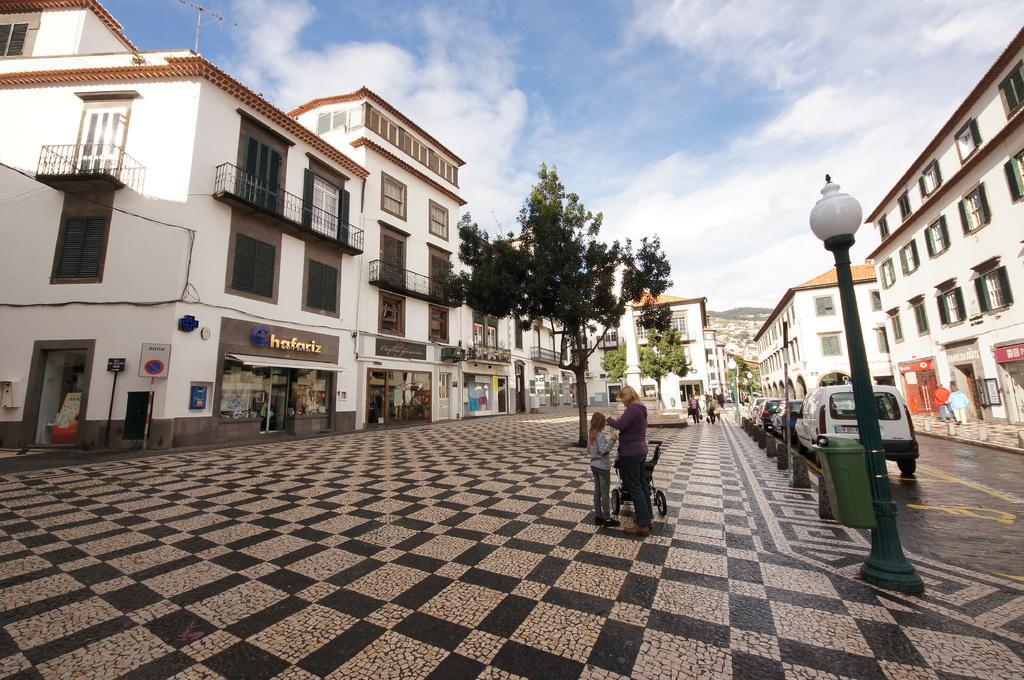How would you summarize this image in a sentence or two? In this image, there are a few buildings. We can see the ground with some objects. We can see some boards with text. There are a few poles. We can see a container attached to one of the poles. There are a few people. We can see a baby trolley. We can see some hills and the sky with clouds. We can see some sign boards. 